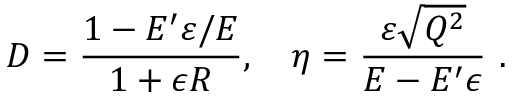<formula> <loc_0><loc_0><loc_500><loc_500>D = { \frac { 1 - E ^ { \prime } \varepsilon / E } { 1 + \epsilon R } } , \quad \eta = { \frac { \varepsilon \sqrt { Q ^ { 2 } } } { E - E ^ { \prime } \epsilon } } \ .</formula> 